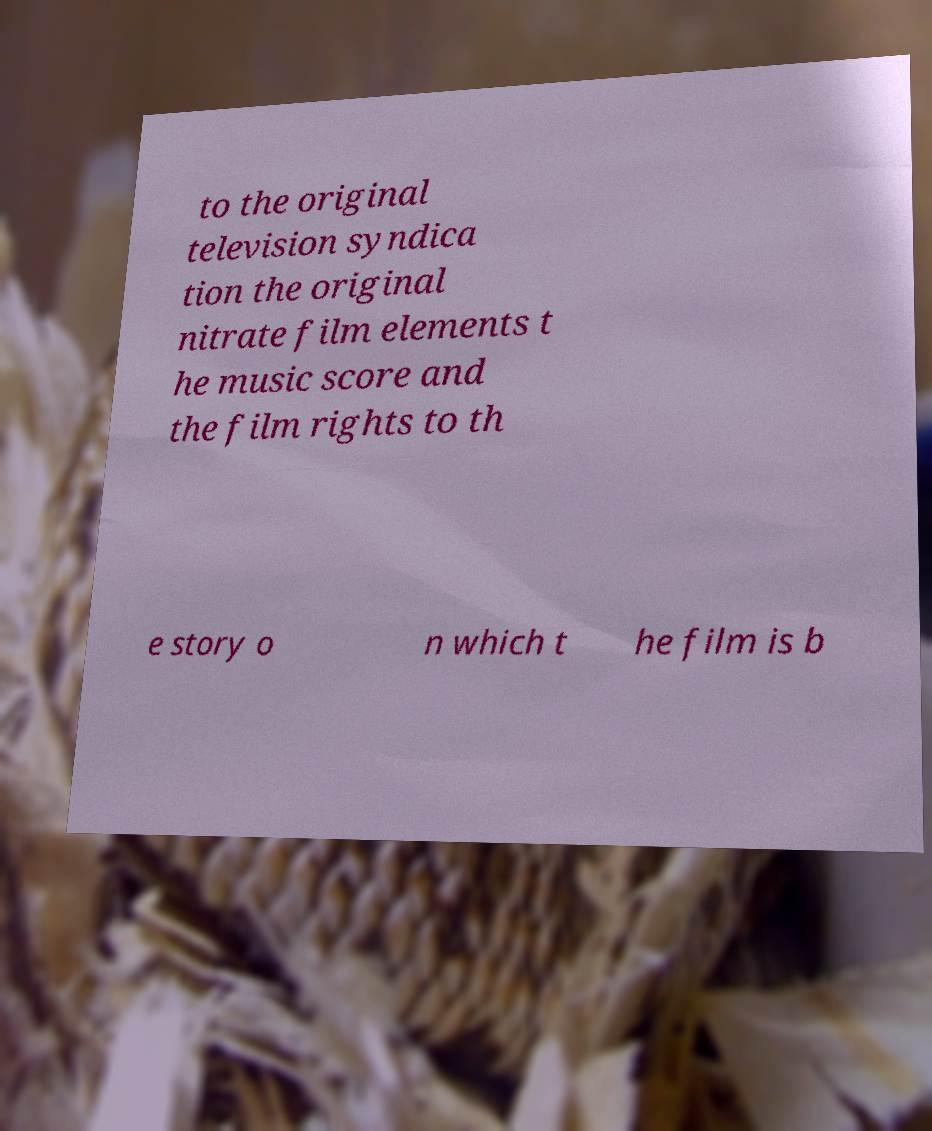Can you accurately transcribe the text from the provided image for me? to the original television syndica tion the original nitrate film elements t he music score and the film rights to th e story o n which t he film is b 